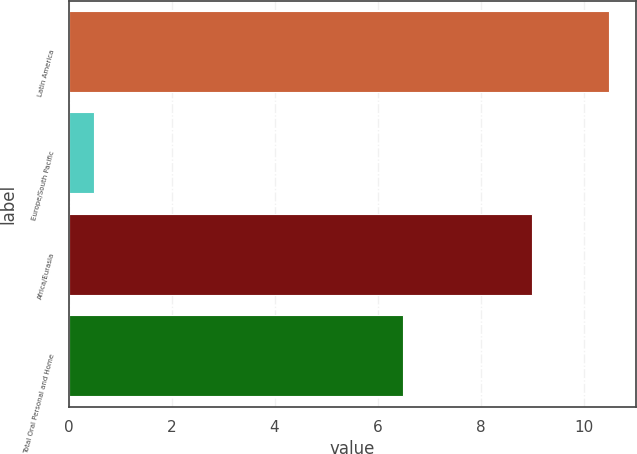Convert chart to OTSL. <chart><loc_0><loc_0><loc_500><loc_500><bar_chart><fcel>Latin America<fcel>Europe/South Pacific<fcel>Africa/Eurasia<fcel>Total Oral Personal and Home<nl><fcel>10.5<fcel>0.5<fcel>9<fcel>6.5<nl></chart> 